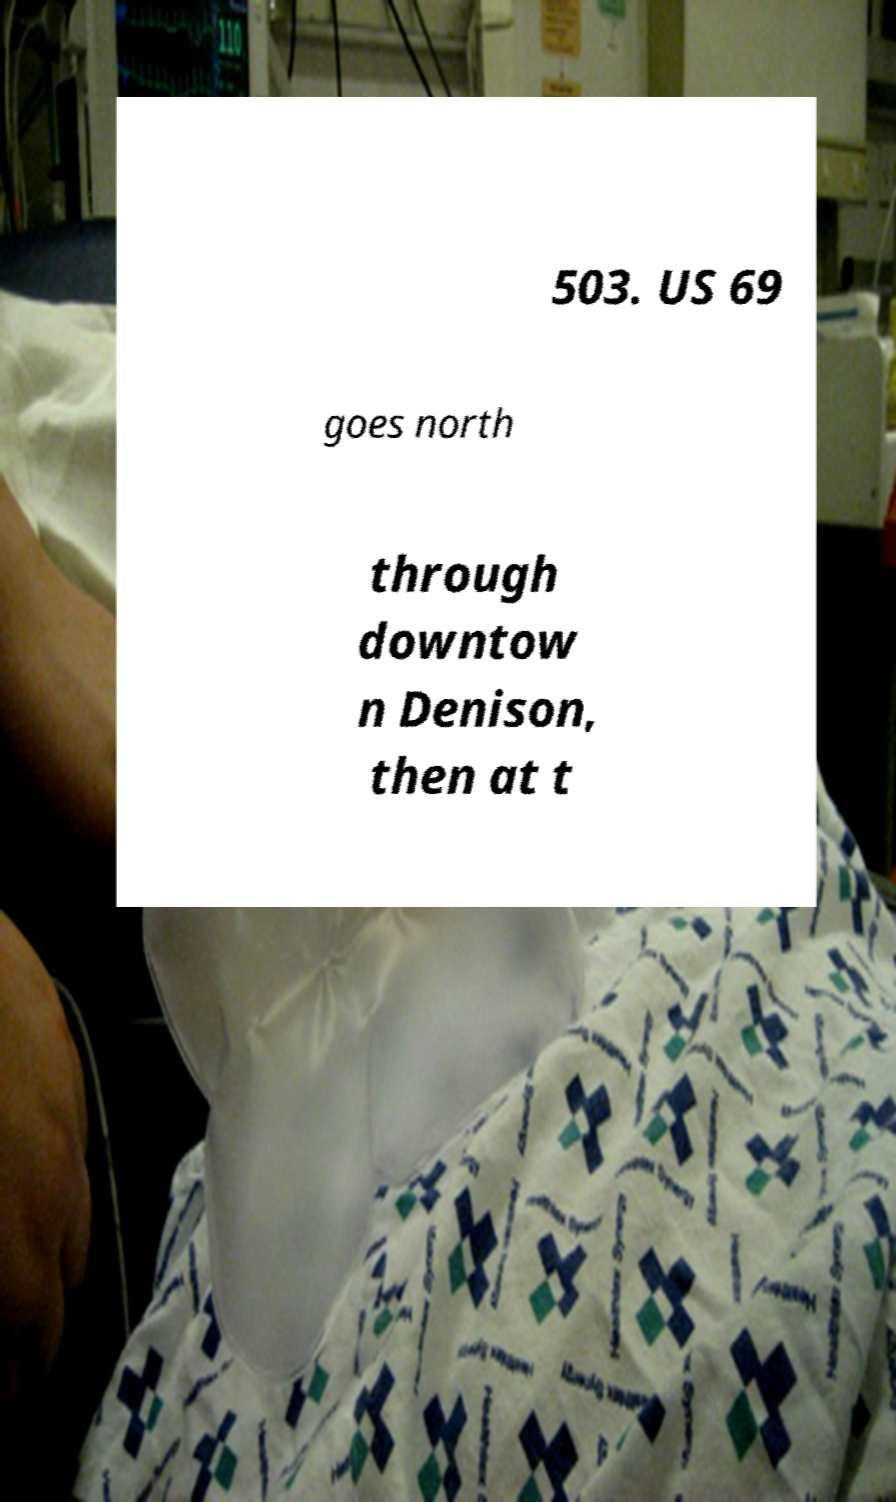Please identify and transcribe the text found in this image. 503. US 69 goes north through downtow n Denison, then at t 